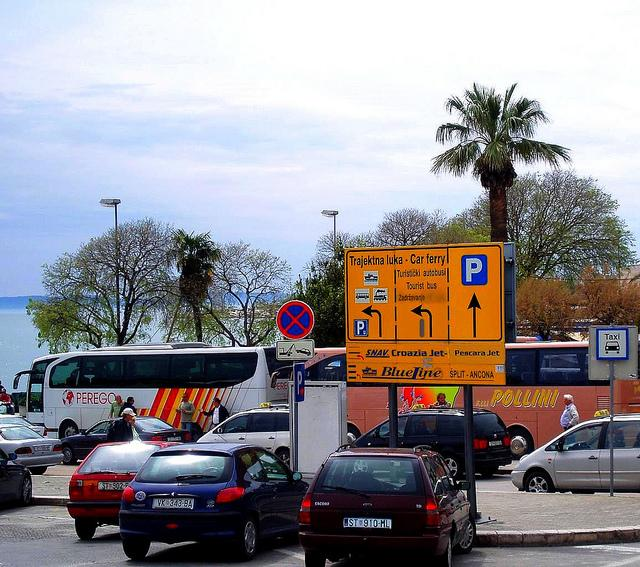How might cars cross the water seen here?

Choices:
A) jump over
B) ferry boat
C) bridge
D) driving ferry boat 